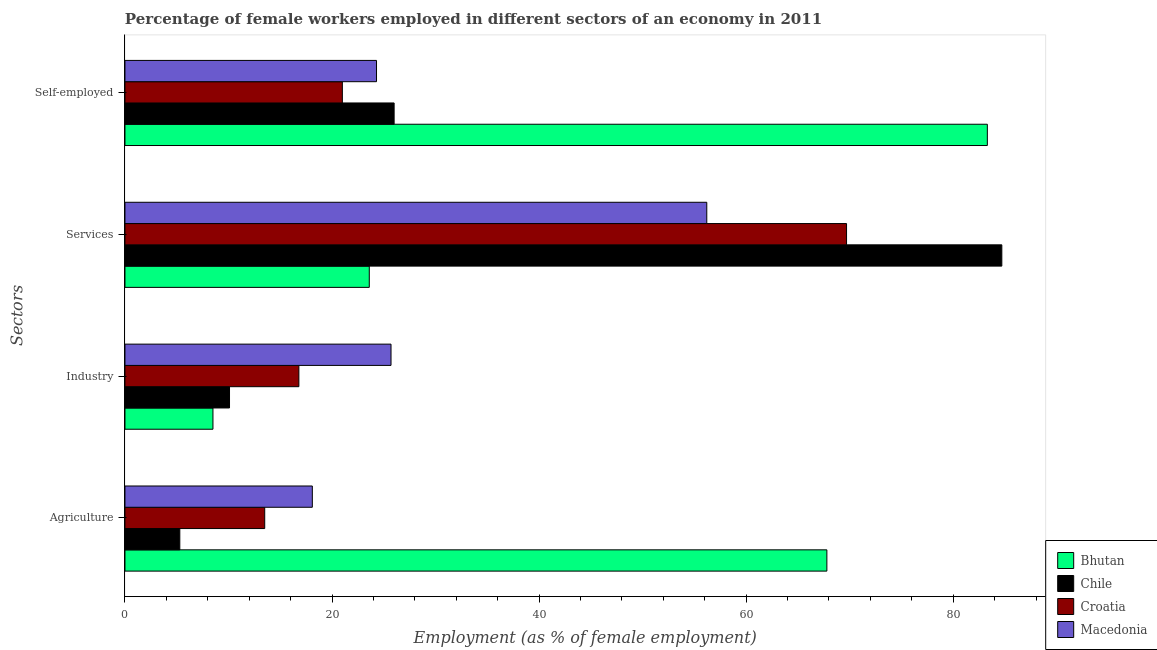How many different coloured bars are there?
Provide a short and direct response. 4. Are the number of bars per tick equal to the number of legend labels?
Offer a terse response. Yes. Are the number of bars on each tick of the Y-axis equal?
Ensure brevity in your answer.  Yes. How many bars are there on the 4th tick from the bottom?
Offer a very short reply. 4. What is the label of the 2nd group of bars from the top?
Give a very brief answer. Services. What is the percentage of self employed female workers in Chile?
Offer a very short reply. 26. Across all countries, what is the maximum percentage of female workers in services?
Offer a terse response. 84.7. In which country was the percentage of self employed female workers maximum?
Your answer should be very brief. Bhutan. In which country was the percentage of female workers in services minimum?
Your response must be concise. Bhutan. What is the total percentage of self employed female workers in the graph?
Ensure brevity in your answer.  154.6. What is the difference between the percentage of female workers in industry in Chile and that in Bhutan?
Offer a terse response. 1.6. What is the difference between the percentage of female workers in services in Bhutan and the percentage of female workers in agriculture in Croatia?
Ensure brevity in your answer.  10.1. What is the average percentage of female workers in industry per country?
Keep it short and to the point. 15.28. What is the difference between the percentage of female workers in agriculture and percentage of female workers in services in Bhutan?
Ensure brevity in your answer.  44.2. What is the ratio of the percentage of self employed female workers in Croatia to that in Bhutan?
Make the answer very short. 0.25. Is the percentage of self employed female workers in Bhutan less than that in Croatia?
Offer a terse response. No. What is the difference between the highest and the second highest percentage of female workers in industry?
Your answer should be compact. 8.9. What is the difference between the highest and the lowest percentage of female workers in services?
Offer a terse response. 61.1. In how many countries, is the percentage of female workers in industry greater than the average percentage of female workers in industry taken over all countries?
Offer a terse response. 2. Is it the case that in every country, the sum of the percentage of female workers in industry and percentage of female workers in agriculture is greater than the sum of percentage of female workers in services and percentage of self employed female workers?
Your answer should be compact. No. What does the 2nd bar from the top in Agriculture represents?
Keep it short and to the point. Croatia. What does the 4th bar from the bottom in Industry represents?
Provide a succinct answer. Macedonia. How many bars are there?
Offer a very short reply. 16. Are all the bars in the graph horizontal?
Provide a succinct answer. Yes. Are the values on the major ticks of X-axis written in scientific E-notation?
Provide a short and direct response. No. Does the graph contain any zero values?
Ensure brevity in your answer.  No. How many legend labels are there?
Provide a succinct answer. 4. How are the legend labels stacked?
Ensure brevity in your answer.  Vertical. What is the title of the graph?
Your response must be concise. Percentage of female workers employed in different sectors of an economy in 2011. Does "Malaysia" appear as one of the legend labels in the graph?
Offer a very short reply. No. What is the label or title of the X-axis?
Provide a short and direct response. Employment (as % of female employment). What is the label or title of the Y-axis?
Ensure brevity in your answer.  Sectors. What is the Employment (as % of female employment) of Bhutan in Agriculture?
Your response must be concise. 67.8. What is the Employment (as % of female employment) in Chile in Agriculture?
Your answer should be compact. 5.3. What is the Employment (as % of female employment) in Macedonia in Agriculture?
Offer a very short reply. 18.1. What is the Employment (as % of female employment) of Bhutan in Industry?
Offer a terse response. 8.5. What is the Employment (as % of female employment) of Chile in Industry?
Provide a succinct answer. 10.1. What is the Employment (as % of female employment) in Croatia in Industry?
Give a very brief answer. 16.8. What is the Employment (as % of female employment) in Macedonia in Industry?
Keep it short and to the point. 25.7. What is the Employment (as % of female employment) of Bhutan in Services?
Your answer should be compact. 23.6. What is the Employment (as % of female employment) of Chile in Services?
Provide a succinct answer. 84.7. What is the Employment (as % of female employment) of Croatia in Services?
Your response must be concise. 69.7. What is the Employment (as % of female employment) of Macedonia in Services?
Provide a short and direct response. 56.2. What is the Employment (as % of female employment) in Bhutan in Self-employed?
Give a very brief answer. 83.3. What is the Employment (as % of female employment) of Chile in Self-employed?
Provide a short and direct response. 26. What is the Employment (as % of female employment) in Macedonia in Self-employed?
Your response must be concise. 24.3. Across all Sectors, what is the maximum Employment (as % of female employment) in Bhutan?
Your answer should be very brief. 83.3. Across all Sectors, what is the maximum Employment (as % of female employment) of Chile?
Your answer should be very brief. 84.7. Across all Sectors, what is the maximum Employment (as % of female employment) in Croatia?
Offer a terse response. 69.7. Across all Sectors, what is the maximum Employment (as % of female employment) of Macedonia?
Your answer should be compact. 56.2. Across all Sectors, what is the minimum Employment (as % of female employment) in Bhutan?
Offer a very short reply. 8.5. Across all Sectors, what is the minimum Employment (as % of female employment) in Chile?
Your answer should be compact. 5.3. Across all Sectors, what is the minimum Employment (as % of female employment) in Macedonia?
Give a very brief answer. 18.1. What is the total Employment (as % of female employment) of Bhutan in the graph?
Your response must be concise. 183.2. What is the total Employment (as % of female employment) in Chile in the graph?
Your answer should be compact. 126.1. What is the total Employment (as % of female employment) in Croatia in the graph?
Provide a short and direct response. 121. What is the total Employment (as % of female employment) of Macedonia in the graph?
Make the answer very short. 124.3. What is the difference between the Employment (as % of female employment) in Bhutan in Agriculture and that in Industry?
Your answer should be very brief. 59.3. What is the difference between the Employment (as % of female employment) of Chile in Agriculture and that in Industry?
Your answer should be compact. -4.8. What is the difference between the Employment (as % of female employment) in Croatia in Agriculture and that in Industry?
Offer a terse response. -3.3. What is the difference between the Employment (as % of female employment) of Bhutan in Agriculture and that in Services?
Your answer should be very brief. 44.2. What is the difference between the Employment (as % of female employment) of Chile in Agriculture and that in Services?
Your answer should be very brief. -79.4. What is the difference between the Employment (as % of female employment) of Croatia in Agriculture and that in Services?
Provide a short and direct response. -56.2. What is the difference between the Employment (as % of female employment) of Macedonia in Agriculture and that in Services?
Make the answer very short. -38.1. What is the difference between the Employment (as % of female employment) of Bhutan in Agriculture and that in Self-employed?
Make the answer very short. -15.5. What is the difference between the Employment (as % of female employment) in Chile in Agriculture and that in Self-employed?
Offer a terse response. -20.7. What is the difference between the Employment (as % of female employment) of Bhutan in Industry and that in Services?
Make the answer very short. -15.1. What is the difference between the Employment (as % of female employment) in Chile in Industry and that in Services?
Ensure brevity in your answer.  -74.6. What is the difference between the Employment (as % of female employment) of Croatia in Industry and that in Services?
Keep it short and to the point. -52.9. What is the difference between the Employment (as % of female employment) of Macedonia in Industry and that in Services?
Provide a short and direct response. -30.5. What is the difference between the Employment (as % of female employment) of Bhutan in Industry and that in Self-employed?
Make the answer very short. -74.8. What is the difference between the Employment (as % of female employment) of Chile in Industry and that in Self-employed?
Your response must be concise. -15.9. What is the difference between the Employment (as % of female employment) in Bhutan in Services and that in Self-employed?
Give a very brief answer. -59.7. What is the difference between the Employment (as % of female employment) in Chile in Services and that in Self-employed?
Your response must be concise. 58.7. What is the difference between the Employment (as % of female employment) of Croatia in Services and that in Self-employed?
Your answer should be compact. 48.7. What is the difference between the Employment (as % of female employment) of Macedonia in Services and that in Self-employed?
Make the answer very short. 31.9. What is the difference between the Employment (as % of female employment) in Bhutan in Agriculture and the Employment (as % of female employment) in Chile in Industry?
Your answer should be compact. 57.7. What is the difference between the Employment (as % of female employment) of Bhutan in Agriculture and the Employment (as % of female employment) of Macedonia in Industry?
Offer a very short reply. 42.1. What is the difference between the Employment (as % of female employment) of Chile in Agriculture and the Employment (as % of female employment) of Macedonia in Industry?
Give a very brief answer. -20.4. What is the difference between the Employment (as % of female employment) in Bhutan in Agriculture and the Employment (as % of female employment) in Chile in Services?
Keep it short and to the point. -16.9. What is the difference between the Employment (as % of female employment) in Bhutan in Agriculture and the Employment (as % of female employment) in Croatia in Services?
Ensure brevity in your answer.  -1.9. What is the difference between the Employment (as % of female employment) of Bhutan in Agriculture and the Employment (as % of female employment) of Macedonia in Services?
Your answer should be very brief. 11.6. What is the difference between the Employment (as % of female employment) of Chile in Agriculture and the Employment (as % of female employment) of Croatia in Services?
Your response must be concise. -64.4. What is the difference between the Employment (as % of female employment) of Chile in Agriculture and the Employment (as % of female employment) of Macedonia in Services?
Keep it short and to the point. -50.9. What is the difference between the Employment (as % of female employment) in Croatia in Agriculture and the Employment (as % of female employment) in Macedonia in Services?
Your answer should be very brief. -42.7. What is the difference between the Employment (as % of female employment) in Bhutan in Agriculture and the Employment (as % of female employment) in Chile in Self-employed?
Give a very brief answer. 41.8. What is the difference between the Employment (as % of female employment) in Bhutan in Agriculture and the Employment (as % of female employment) in Croatia in Self-employed?
Make the answer very short. 46.8. What is the difference between the Employment (as % of female employment) of Bhutan in Agriculture and the Employment (as % of female employment) of Macedonia in Self-employed?
Give a very brief answer. 43.5. What is the difference between the Employment (as % of female employment) in Chile in Agriculture and the Employment (as % of female employment) in Croatia in Self-employed?
Your answer should be very brief. -15.7. What is the difference between the Employment (as % of female employment) of Bhutan in Industry and the Employment (as % of female employment) of Chile in Services?
Make the answer very short. -76.2. What is the difference between the Employment (as % of female employment) in Bhutan in Industry and the Employment (as % of female employment) in Croatia in Services?
Provide a succinct answer. -61.2. What is the difference between the Employment (as % of female employment) of Bhutan in Industry and the Employment (as % of female employment) of Macedonia in Services?
Offer a very short reply. -47.7. What is the difference between the Employment (as % of female employment) in Chile in Industry and the Employment (as % of female employment) in Croatia in Services?
Your answer should be compact. -59.6. What is the difference between the Employment (as % of female employment) in Chile in Industry and the Employment (as % of female employment) in Macedonia in Services?
Your answer should be very brief. -46.1. What is the difference between the Employment (as % of female employment) of Croatia in Industry and the Employment (as % of female employment) of Macedonia in Services?
Give a very brief answer. -39.4. What is the difference between the Employment (as % of female employment) in Bhutan in Industry and the Employment (as % of female employment) in Chile in Self-employed?
Offer a terse response. -17.5. What is the difference between the Employment (as % of female employment) of Bhutan in Industry and the Employment (as % of female employment) of Croatia in Self-employed?
Make the answer very short. -12.5. What is the difference between the Employment (as % of female employment) in Bhutan in Industry and the Employment (as % of female employment) in Macedonia in Self-employed?
Your response must be concise. -15.8. What is the difference between the Employment (as % of female employment) of Chile in Industry and the Employment (as % of female employment) of Croatia in Self-employed?
Ensure brevity in your answer.  -10.9. What is the difference between the Employment (as % of female employment) of Chile in Industry and the Employment (as % of female employment) of Macedonia in Self-employed?
Ensure brevity in your answer.  -14.2. What is the difference between the Employment (as % of female employment) of Croatia in Industry and the Employment (as % of female employment) of Macedonia in Self-employed?
Keep it short and to the point. -7.5. What is the difference between the Employment (as % of female employment) in Bhutan in Services and the Employment (as % of female employment) in Chile in Self-employed?
Offer a very short reply. -2.4. What is the difference between the Employment (as % of female employment) in Chile in Services and the Employment (as % of female employment) in Croatia in Self-employed?
Give a very brief answer. 63.7. What is the difference between the Employment (as % of female employment) of Chile in Services and the Employment (as % of female employment) of Macedonia in Self-employed?
Ensure brevity in your answer.  60.4. What is the difference between the Employment (as % of female employment) of Croatia in Services and the Employment (as % of female employment) of Macedonia in Self-employed?
Your answer should be compact. 45.4. What is the average Employment (as % of female employment) in Bhutan per Sectors?
Offer a terse response. 45.8. What is the average Employment (as % of female employment) of Chile per Sectors?
Provide a short and direct response. 31.52. What is the average Employment (as % of female employment) in Croatia per Sectors?
Offer a very short reply. 30.25. What is the average Employment (as % of female employment) in Macedonia per Sectors?
Provide a short and direct response. 31.07. What is the difference between the Employment (as % of female employment) of Bhutan and Employment (as % of female employment) of Chile in Agriculture?
Ensure brevity in your answer.  62.5. What is the difference between the Employment (as % of female employment) in Bhutan and Employment (as % of female employment) in Croatia in Agriculture?
Offer a terse response. 54.3. What is the difference between the Employment (as % of female employment) in Bhutan and Employment (as % of female employment) in Macedonia in Agriculture?
Give a very brief answer. 49.7. What is the difference between the Employment (as % of female employment) in Chile and Employment (as % of female employment) in Croatia in Agriculture?
Ensure brevity in your answer.  -8.2. What is the difference between the Employment (as % of female employment) in Chile and Employment (as % of female employment) in Macedonia in Agriculture?
Provide a succinct answer. -12.8. What is the difference between the Employment (as % of female employment) in Croatia and Employment (as % of female employment) in Macedonia in Agriculture?
Keep it short and to the point. -4.6. What is the difference between the Employment (as % of female employment) in Bhutan and Employment (as % of female employment) in Chile in Industry?
Your answer should be compact. -1.6. What is the difference between the Employment (as % of female employment) of Bhutan and Employment (as % of female employment) of Croatia in Industry?
Provide a short and direct response. -8.3. What is the difference between the Employment (as % of female employment) of Bhutan and Employment (as % of female employment) of Macedonia in Industry?
Your answer should be compact. -17.2. What is the difference between the Employment (as % of female employment) in Chile and Employment (as % of female employment) in Croatia in Industry?
Your response must be concise. -6.7. What is the difference between the Employment (as % of female employment) of Chile and Employment (as % of female employment) of Macedonia in Industry?
Offer a very short reply. -15.6. What is the difference between the Employment (as % of female employment) in Croatia and Employment (as % of female employment) in Macedonia in Industry?
Offer a very short reply. -8.9. What is the difference between the Employment (as % of female employment) of Bhutan and Employment (as % of female employment) of Chile in Services?
Provide a short and direct response. -61.1. What is the difference between the Employment (as % of female employment) of Bhutan and Employment (as % of female employment) of Croatia in Services?
Ensure brevity in your answer.  -46.1. What is the difference between the Employment (as % of female employment) of Bhutan and Employment (as % of female employment) of Macedonia in Services?
Provide a short and direct response. -32.6. What is the difference between the Employment (as % of female employment) in Bhutan and Employment (as % of female employment) in Chile in Self-employed?
Ensure brevity in your answer.  57.3. What is the difference between the Employment (as % of female employment) of Bhutan and Employment (as % of female employment) of Croatia in Self-employed?
Your answer should be very brief. 62.3. What is the difference between the Employment (as % of female employment) in Bhutan and Employment (as % of female employment) in Macedonia in Self-employed?
Your answer should be very brief. 59. What is the difference between the Employment (as % of female employment) in Chile and Employment (as % of female employment) in Croatia in Self-employed?
Give a very brief answer. 5. What is the difference between the Employment (as % of female employment) in Chile and Employment (as % of female employment) in Macedonia in Self-employed?
Your answer should be compact. 1.7. What is the difference between the Employment (as % of female employment) of Croatia and Employment (as % of female employment) of Macedonia in Self-employed?
Your response must be concise. -3.3. What is the ratio of the Employment (as % of female employment) in Bhutan in Agriculture to that in Industry?
Your response must be concise. 7.98. What is the ratio of the Employment (as % of female employment) of Chile in Agriculture to that in Industry?
Make the answer very short. 0.52. What is the ratio of the Employment (as % of female employment) in Croatia in Agriculture to that in Industry?
Give a very brief answer. 0.8. What is the ratio of the Employment (as % of female employment) of Macedonia in Agriculture to that in Industry?
Your response must be concise. 0.7. What is the ratio of the Employment (as % of female employment) in Bhutan in Agriculture to that in Services?
Provide a short and direct response. 2.87. What is the ratio of the Employment (as % of female employment) in Chile in Agriculture to that in Services?
Provide a short and direct response. 0.06. What is the ratio of the Employment (as % of female employment) of Croatia in Agriculture to that in Services?
Offer a terse response. 0.19. What is the ratio of the Employment (as % of female employment) in Macedonia in Agriculture to that in Services?
Ensure brevity in your answer.  0.32. What is the ratio of the Employment (as % of female employment) of Bhutan in Agriculture to that in Self-employed?
Keep it short and to the point. 0.81. What is the ratio of the Employment (as % of female employment) in Chile in Agriculture to that in Self-employed?
Your answer should be very brief. 0.2. What is the ratio of the Employment (as % of female employment) of Croatia in Agriculture to that in Self-employed?
Your response must be concise. 0.64. What is the ratio of the Employment (as % of female employment) in Macedonia in Agriculture to that in Self-employed?
Provide a short and direct response. 0.74. What is the ratio of the Employment (as % of female employment) of Bhutan in Industry to that in Services?
Make the answer very short. 0.36. What is the ratio of the Employment (as % of female employment) in Chile in Industry to that in Services?
Your response must be concise. 0.12. What is the ratio of the Employment (as % of female employment) of Croatia in Industry to that in Services?
Make the answer very short. 0.24. What is the ratio of the Employment (as % of female employment) of Macedonia in Industry to that in Services?
Provide a short and direct response. 0.46. What is the ratio of the Employment (as % of female employment) in Bhutan in Industry to that in Self-employed?
Your answer should be compact. 0.1. What is the ratio of the Employment (as % of female employment) in Chile in Industry to that in Self-employed?
Your answer should be very brief. 0.39. What is the ratio of the Employment (as % of female employment) in Macedonia in Industry to that in Self-employed?
Your response must be concise. 1.06. What is the ratio of the Employment (as % of female employment) in Bhutan in Services to that in Self-employed?
Give a very brief answer. 0.28. What is the ratio of the Employment (as % of female employment) of Chile in Services to that in Self-employed?
Offer a very short reply. 3.26. What is the ratio of the Employment (as % of female employment) of Croatia in Services to that in Self-employed?
Offer a very short reply. 3.32. What is the ratio of the Employment (as % of female employment) of Macedonia in Services to that in Self-employed?
Offer a very short reply. 2.31. What is the difference between the highest and the second highest Employment (as % of female employment) of Bhutan?
Provide a succinct answer. 15.5. What is the difference between the highest and the second highest Employment (as % of female employment) of Chile?
Keep it short and to the point. 58.7. What is the difference between the highest and the second highest Employment (as % of female employment) of Croatia?
Provide a succinct answer. 48.7. What is the difference between the highest and the second highest Employment (as % of female employment) in Macedonia?
Offer a terse response. 30.5. What is the difference between the highest and the lowest Employment (as % of female employment) of Bhutan?
Give a very brief answer. 74.8. What is the difference between the highest and the lowest Employment (as % of female employment) in Chile?
Make the answer very short. 79.4. What is the difference between the highest and the lowest Employment (as % of female employment) of Croatia?
Offer a terse response. 56.2. What is the difference between the highest and the lowest Employment (as % of female employment) of Macedonia?
Offer a terse response. 38.1. 